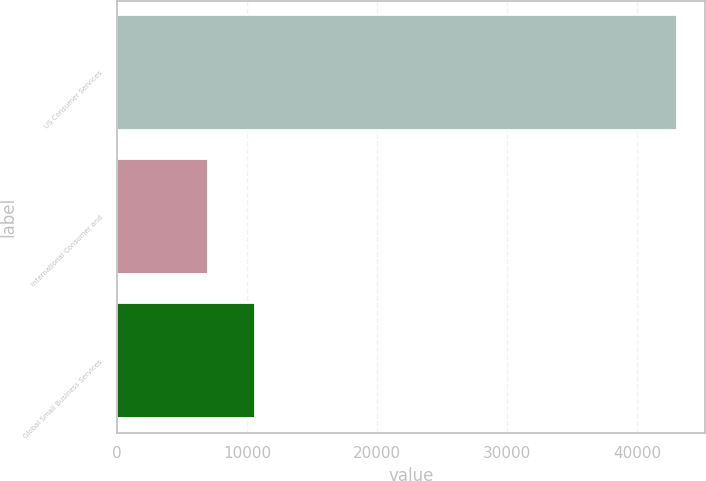Convert chart. <chart><loc_0><loc_0><loc_500><loc_500><bar_chart><fcel>US Consumer Services<fcel>International Consumer and<fcel>Global Small Business Services<nl><fcel>43063<fcel>6961<fcel>10571.2<nl></chart> 